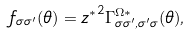<formula> <loc_0><loc_0><loc_500><loc_500>f _ { \sigma \sigma ^ { \prime } } ( \theta ) = { z ^ { * } } ^ { 2 } \Gamma ^ { \Omega * } _ { \sigma \sigma ^ { \prime } , \sigma ^ { \prime } \sigma } ( \theta ) ,</formula> 